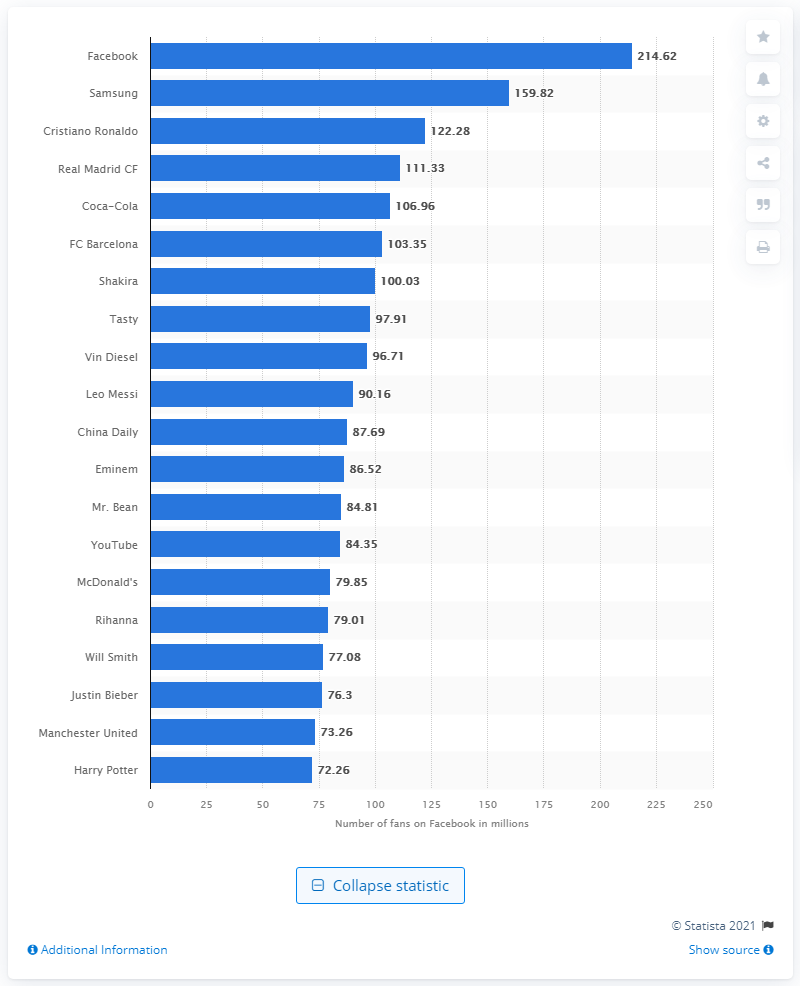Draw attention to some important aspects in this diagram. Samsung is the tech conglomerate with the most followers on Facebook. In June 2021, there were 122.28 people who subscribed to Cristiano Ronaldo's Facebook page. 